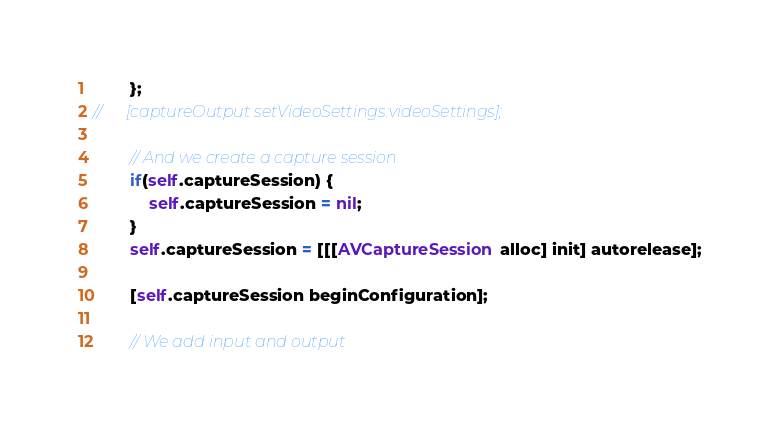Convert code to text. <code><loc_0><loc_0><loc_500><loc_500><_ObjectiveC_>		};
//		[captureOutput setVideoSettings:videoSettings];

		// And we create a capture session
		if(self.captureSession) {
			self.captureSession = nil;
		}
		self.captureSession = [[[AVCaptureSession alloc] init] autorelease];

		[self.captureSession beginConfiguration];

		// We add input and output</code> 